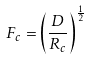<formula> <loc_0><loc_0><loc_500><loc_500>F _ { c } = \left ( \frac { D } { R _ { c } } \right ) ^ { \frac { 1 } { 2 } }</formula> 